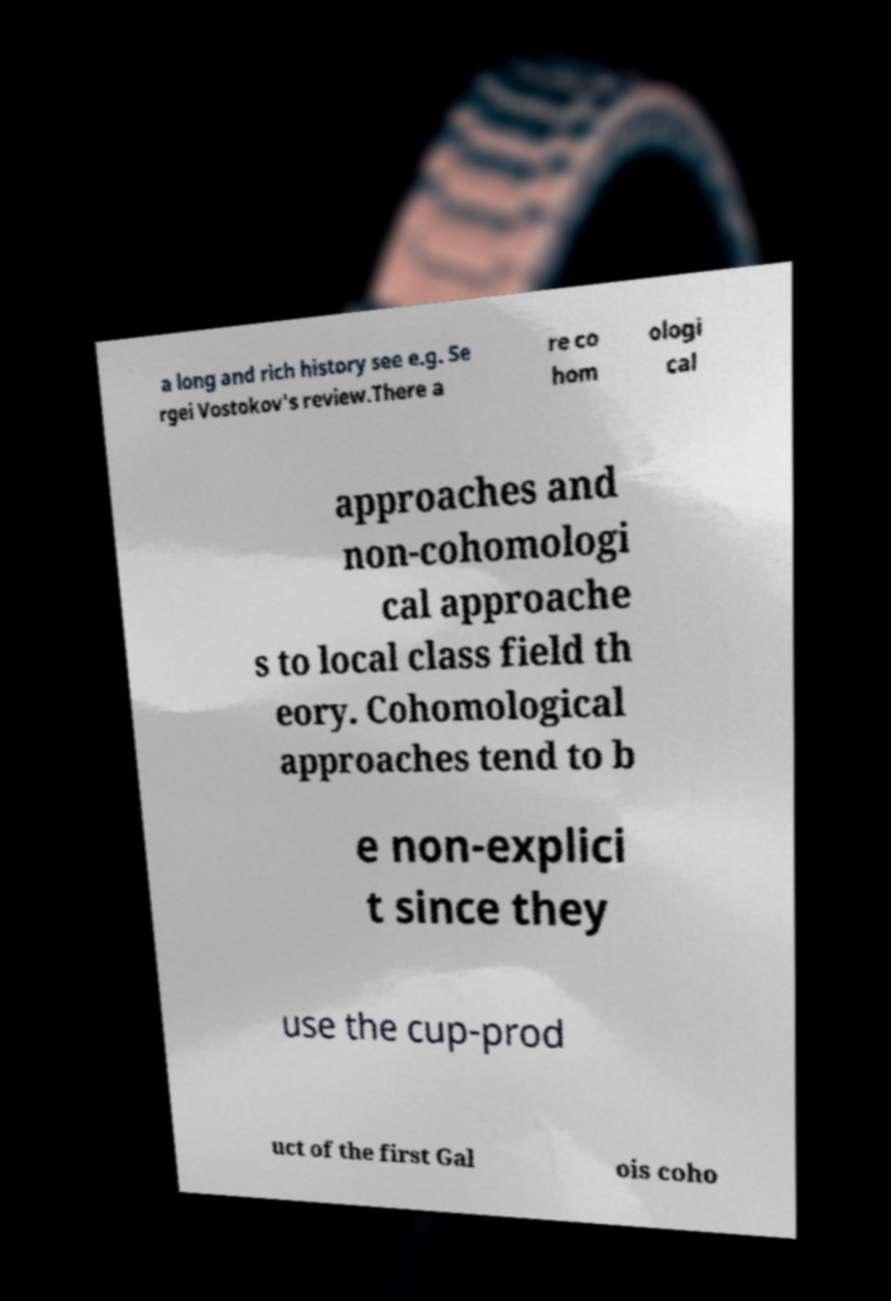Could you extract and type out the text from this image? a long and rich history see e.g. Se rgei Vostokov's review.There a re co hom ologi cal approaches and non-cohomologi cal approache s to local class field th eory. Cohomological approaches tend to b e non-explici t since they use the cup-prod uct of the first Gal ois coho 